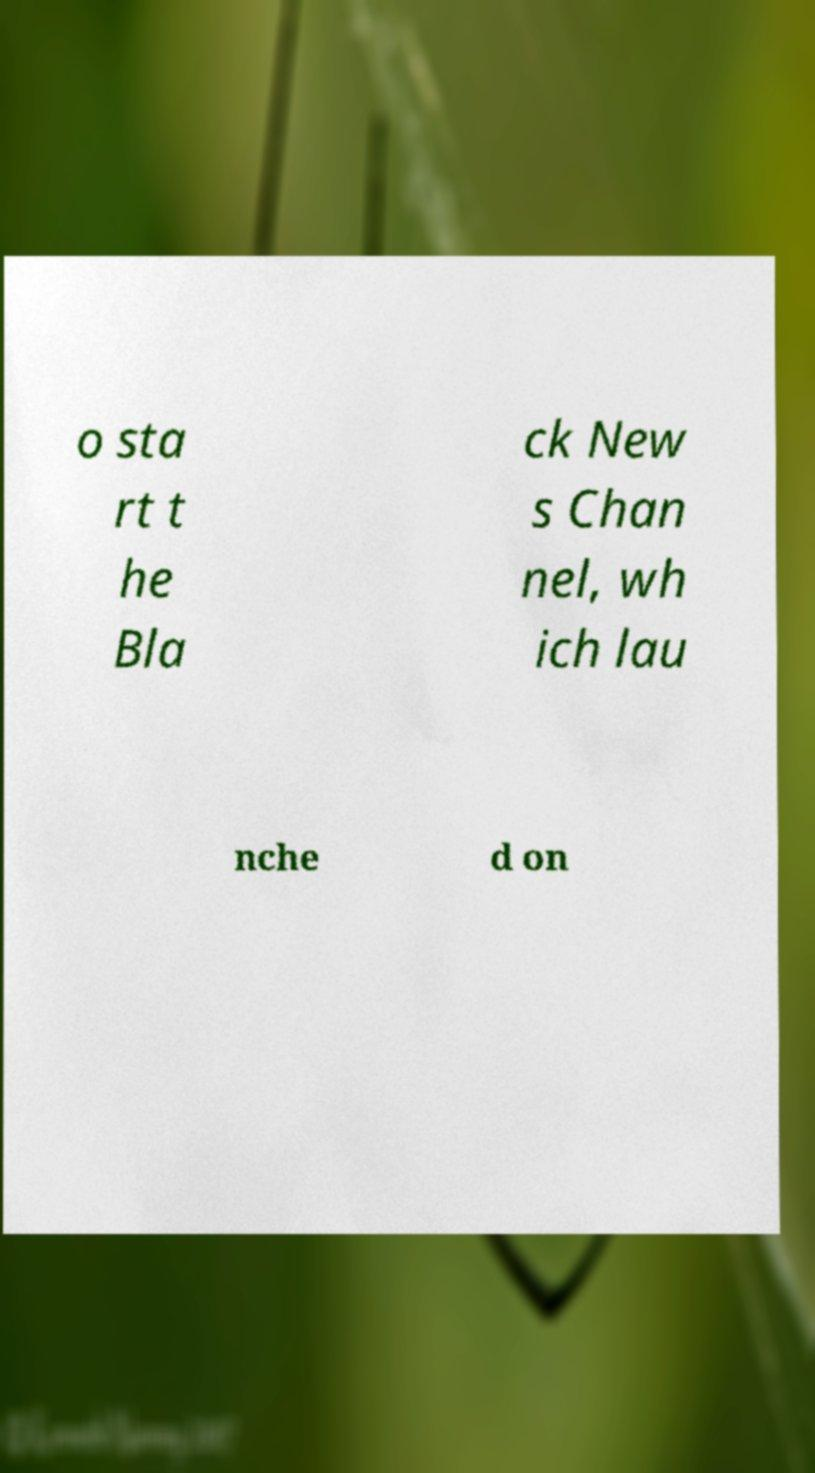Please identify and transcribe the text found in this image. o sta rt t he Bla ck New s Chan nel, wh ich lau nche d on 